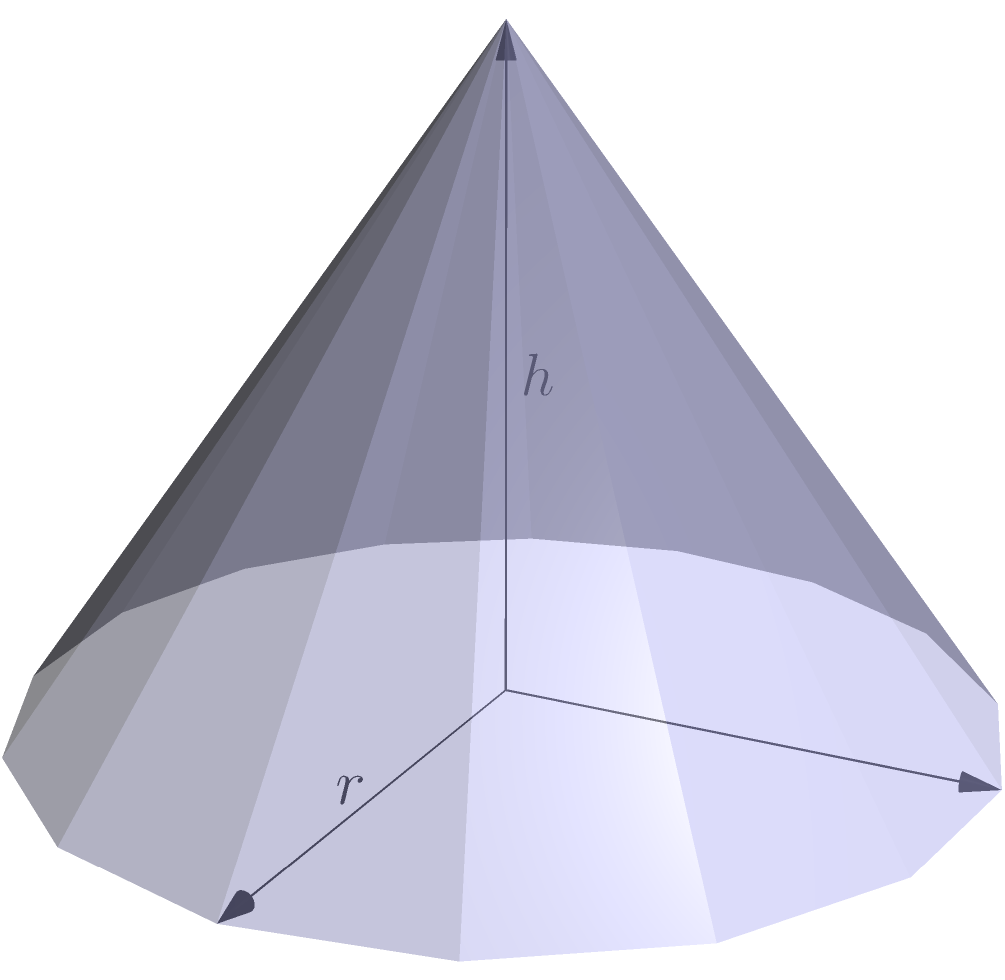A nomadic tribe uses conical tents in their travels across ancient steppes. The radius of the base of their tent is 3 meters, and the height is 4 meters. Calculate the volume of this tent, demonstrating how historical knowledge of geometry can be applied to understand ancient living conditions. To solve this problem, we'll use the formula for the volume of a cone and apply it to the historical context of nomadic tent design:

1. Recall the formula for the volume of a cone:
   $$ V = \frac{1}{3}\pi r^2 h $$
   where $r$ is the radius of the base and $h$ is the height.

2. Given information:
   - Radius ($r$) = 3 meters
   - Height ($h$) = 4 meters

3. Substitute the values into the formula:
   $$ V = \frac{1}{3}\pi (3\text{ m})^2 (4\text{ m}) $$

4. Simplify:
   $$ V = \frac{1}{3}\pi (9\text{ m}^2) (4\text{ m}) = 12\pi \text{ m}^3 $$

5. Calculate the final value:
   $$ V \approx 37.70 \text{ m}^3 $$

This volume represents the living space available to the nomads, demonstrating how ancient cultures optimized their portable dwellings for both space efficiency and structural stability.
Answer: $37.70 \text{ m}^3$ 